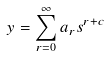<formula> <loc_0><loc_0><loc_500><loc_500>y = \sum _ { r = 0 } ^ { \infty } a _ { r } s ^ { r + c }</formula> 